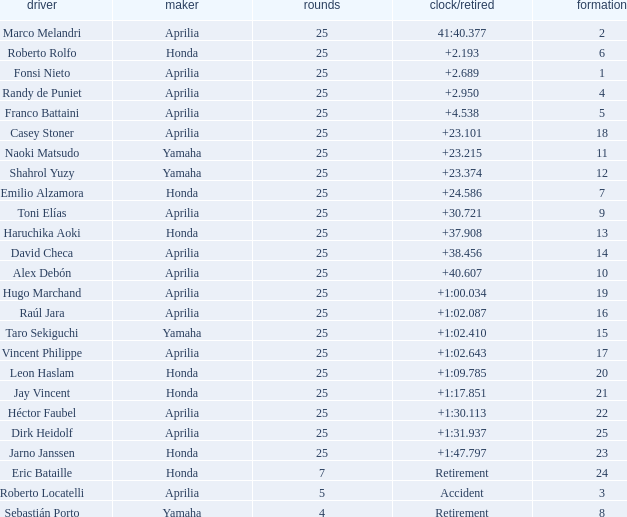Which Grid has Laps of 25, and a Manufacturer of honda, and a Time/Retired of +1:47.797? 23.0. 